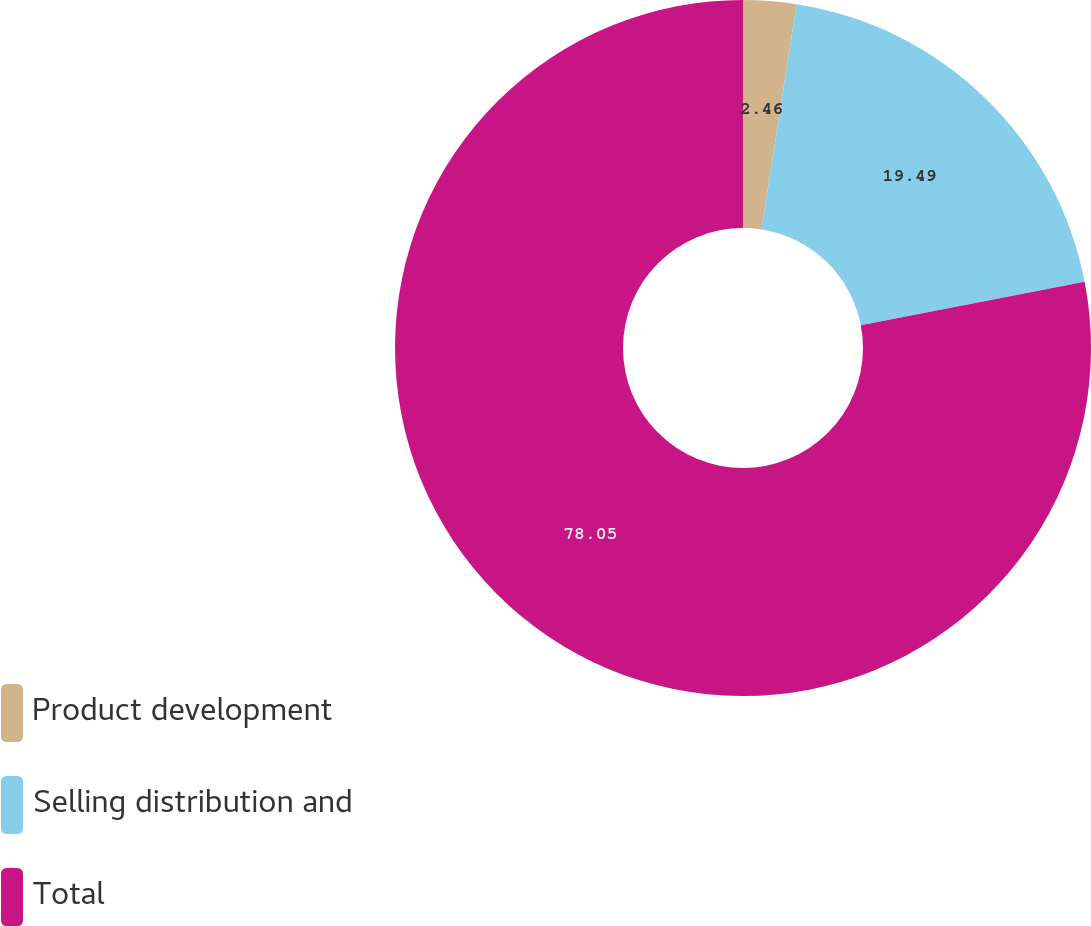Convert chart to OTSL. <chart><loc_0><loc_0><loc_500><loc_500><pie_chart><fcel>Product development<fcel>Selling distribution and<fcel>Total<nl><fcel>2.46%<fcel>19.49%<fcel>78.05%<nl></chart> 